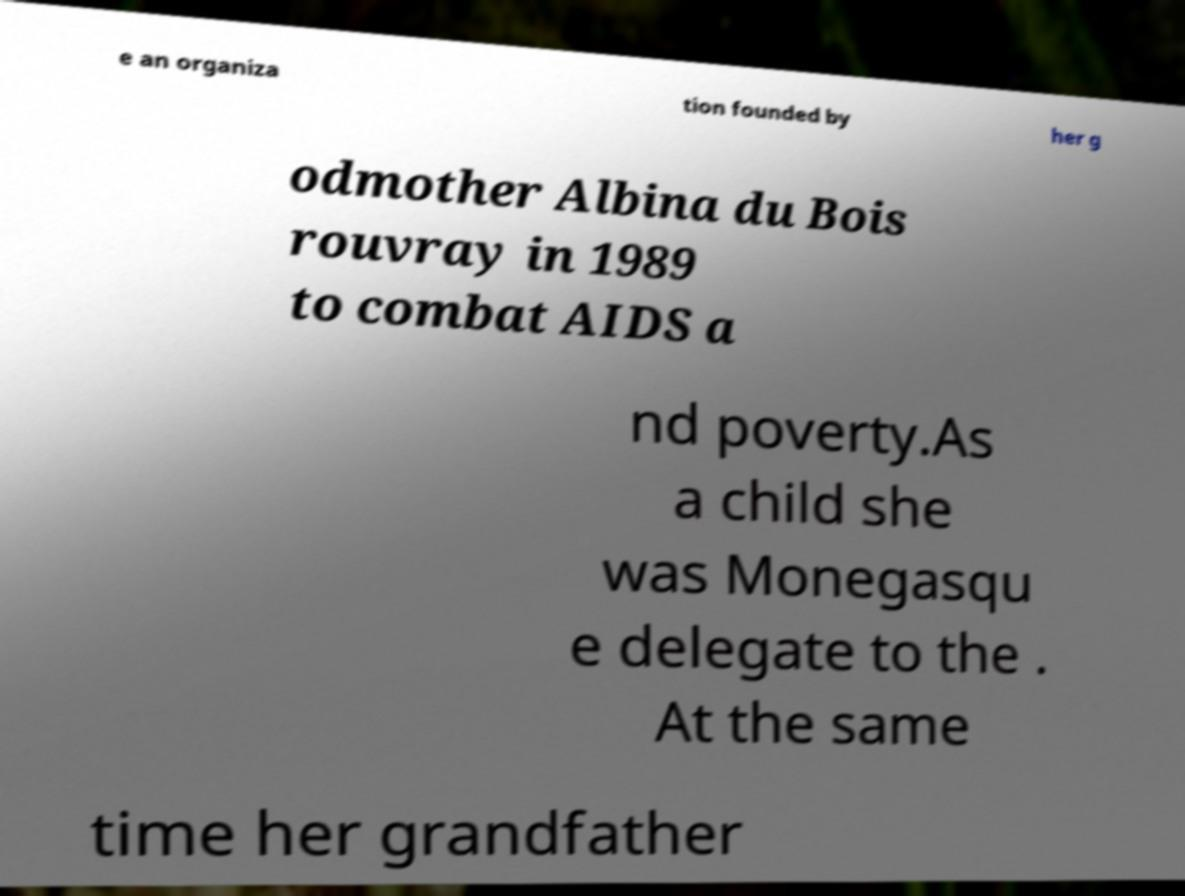Can you accurately transcribe the text from the provided image for me? e an organiza tion founded by her g odmother Albina du Bois rouvray in 1989 to combat AIDS a nd poverty.As a child she was Monegasqu e delegate to the . At the same time her grandfather 